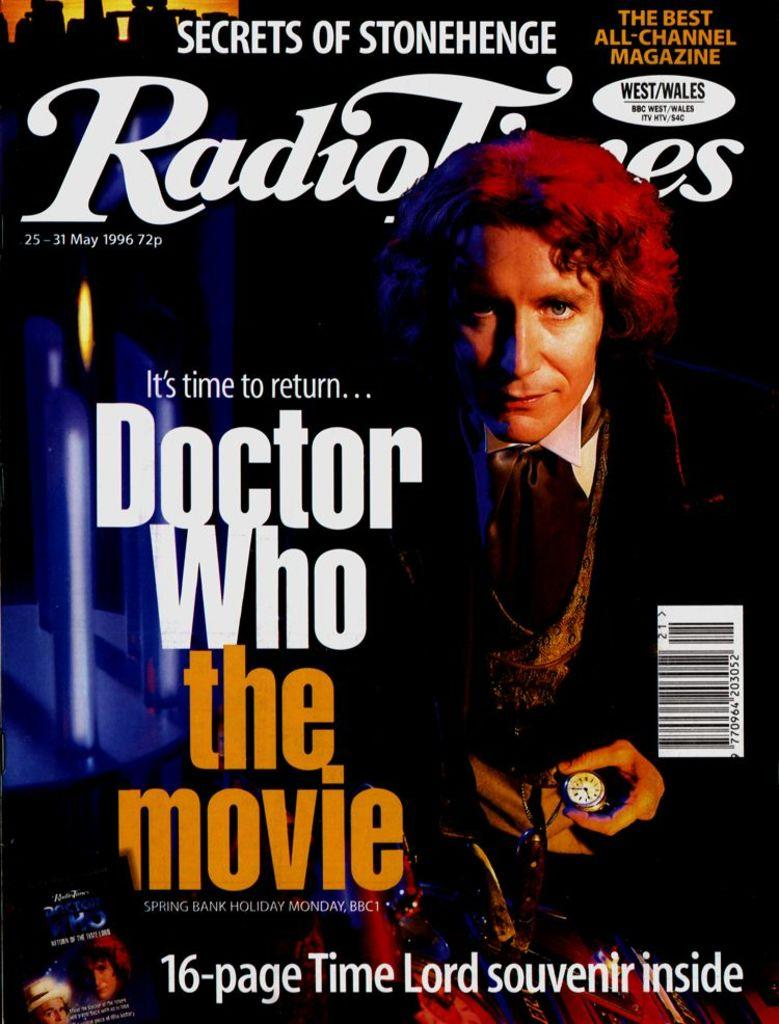Provide a one-sentence caption for the provided image. A magazine advertises the Doctor Who movie and a souvenir inside. 